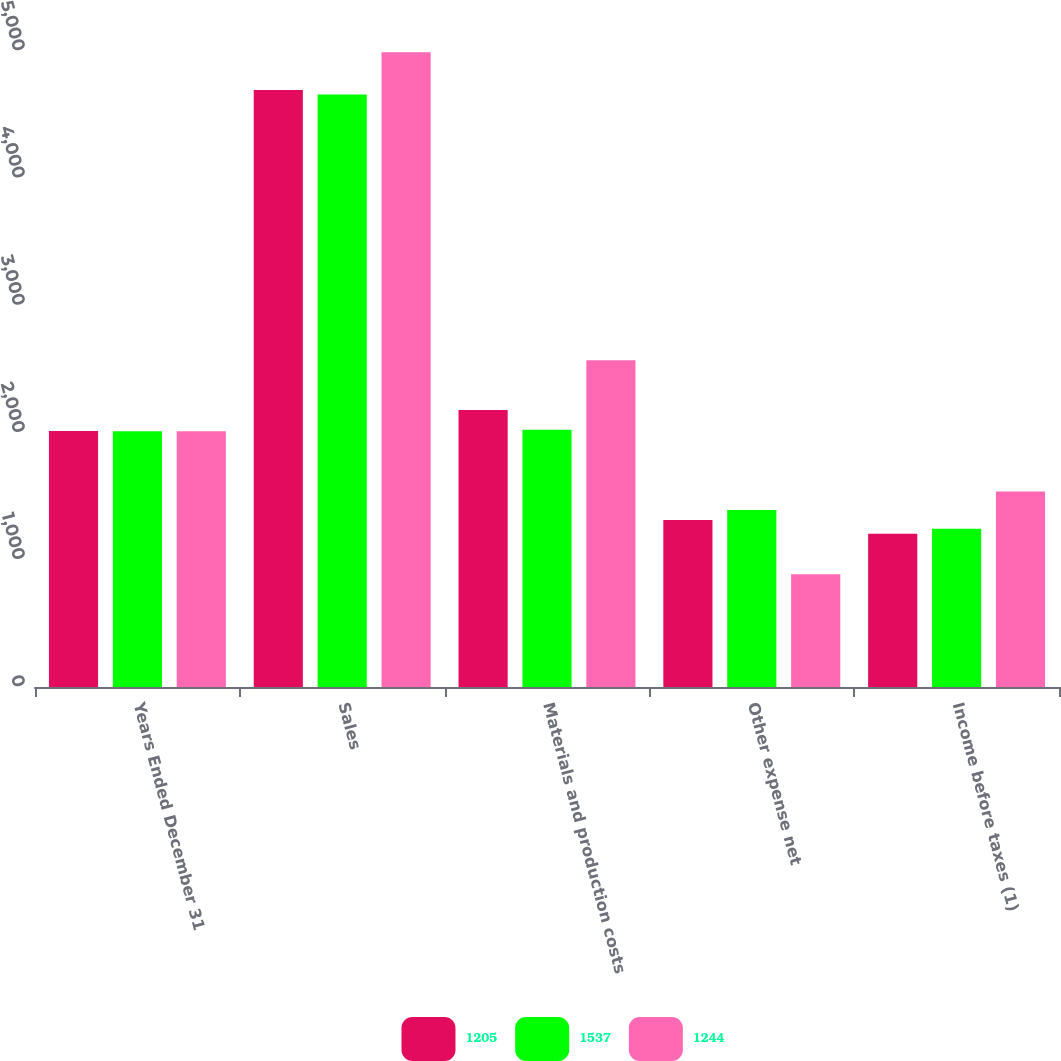Convert chart to OTSL. <chart><loc_0><loc_0><loc_500><loc_500><stacked_bar_chart><ecel><fcel>Years Ended December 31<fcel>Sales<fcel>Materials and production costs<fcel>Other expense net<fcel>Income before taxes (1)<nl><fcel>1205<fcel>2012<fcel>4694<fcel>2177<fcel>1312<fcel>1205<nl><fcel>1537<fcel>2011<fcel>4659<fcel>2023<fcel>1392<fcel>1244<nl><fcel>1244<fcel>2010<fcel>4991<fcel>2568<fcel>886<fcel>1537<nl></chart> 